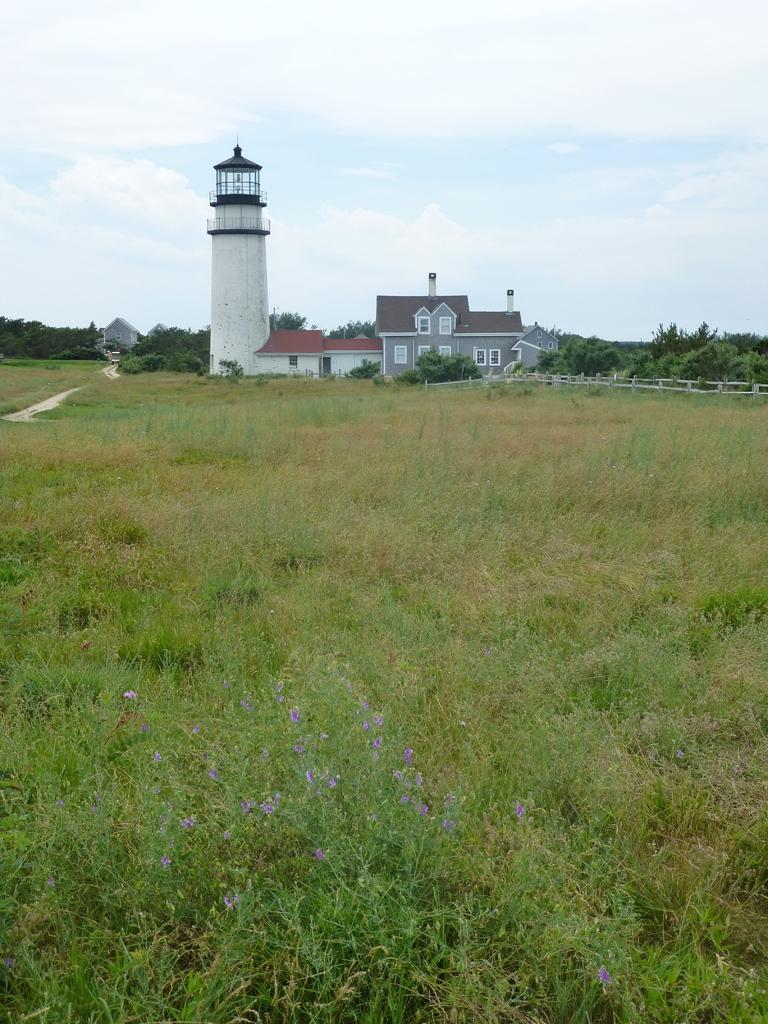What type of structures can be seen in the image? There are buildings in the image. What can be seen beneath the buildings and plants? The ground is visible in the image. What type of vegetation is present in the image? There is grass, plants, and trees in the image. What is used to separate the area from another? There is a fence in the image. What is visible above the buildings and vegetation? The sky is visible in the image. What can be observed in the sky? Clouds are present in the sky. Can you see the nose of the person walking in the image? There is no person walking in the image, and therefore no nose can be seen. What type of spot can be seen on the tree in the image? There is no spot visible on the trees in the image. 